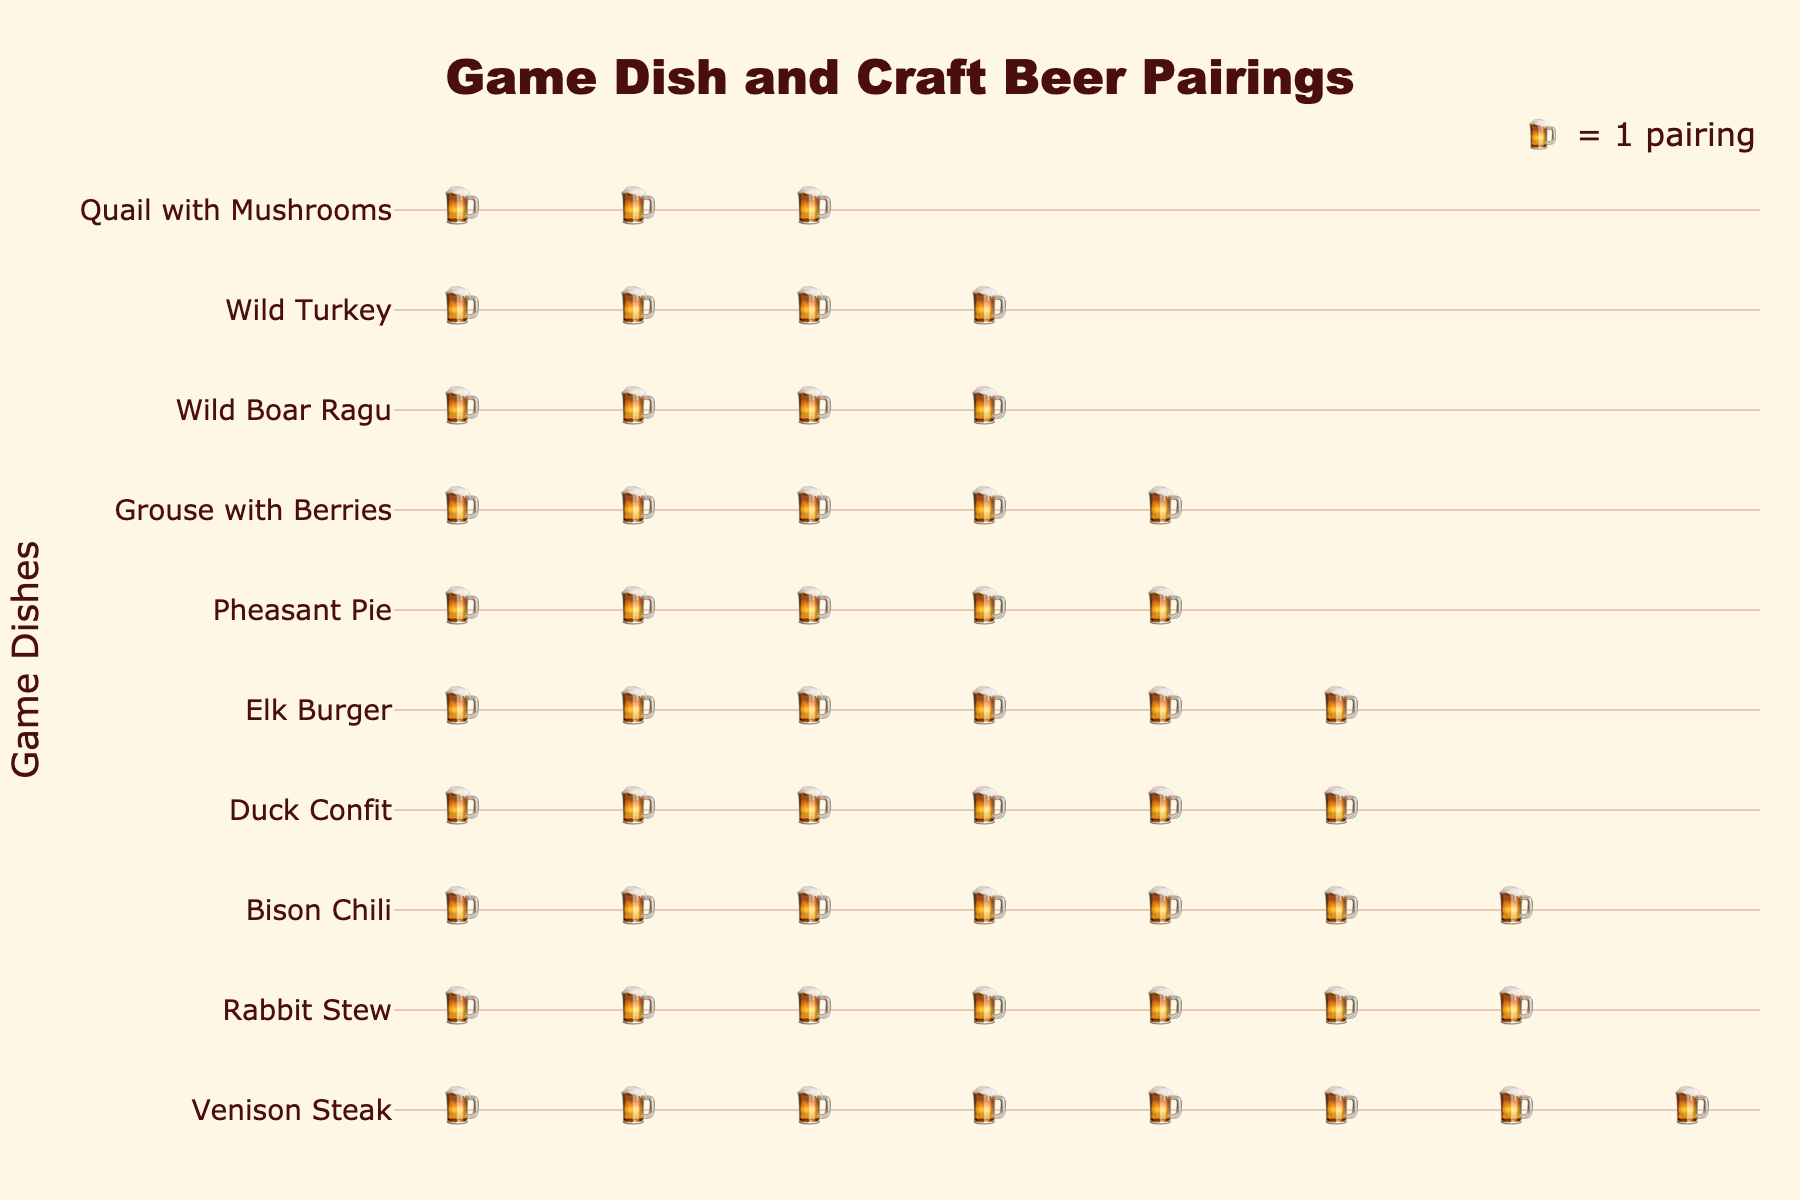what is the title of the plot? The title is typically placed at the top center of the plot. In this case, it should indicate the context of the data being visualized. The title reads "Game Dish and Craft Beer Pairings".
Answer: Game Dish and Craft Beer Pairings How many pairings are there for Bison Chili? Each beer mug icon represents one pairing. By counting the number of beer mugs next to Bison Chili, you can determine the total pairings. There are 7 beer mugs next to Bison Chili.
Answer: 7 Which game dish is paired with an Imperial Stout? The hover information typically includes the beer style along with the game dish. By looking at the icons and hover information, it's evident that an Imperial Stout is paired with Venison Steak.
Answer: Venison Steak What is the game dish with the least number of pairings? The dish with the least number of beer mugs next to it has the least pairings. By counting, Quail with Mushrooms has the fewest pairings with 3.
Answer: Quail with Mushrooms How many total pairings are depicted in the plot? Sum all the pairings for each game dish. These are: 8, 6, 5, 4, 7, 3, 5, 6, 4, 7. The total is 8 + 6 + 5 + 4 + 7 + 3 + 5 + 6 + 4 + 7 = 55.
Answer: 55 Which game dish has more pairings, Wild Boar Ragu or Rabbit Stew? Compare the number of beer mug icons next to each dish. Wild Boar Ragu has 4 pairings, and Rabbit Stew has 7 pairings. Rabbit Stew has more pairings.
Answer: Rabbit Stew What is the average number of pairings per game dish? To find the average, divide the total number of pairings by the number of game dishes. There are 55 total pairings across 10 dishes. 55 / 10 = 5.5.
Answer: 5.5 Which beer style is paired with Duck Confit? The hover information or pairing icons next to Duck Confit will show the beer style. Duck Confit is paired with Belgian Dubbel.
Answer: Belgian Dubbel How does the number of pairings for Elk Burger compare to that for American IPA? The same dish cannot have different beer styles; rather, we need to find the beer style for Elk Burger. Elk Burger is paired with American IPA with 6 pairings each, so they are the same.
Answer: Same What is the median number of pairings for the game dishes? To find the median, list the number of pairings in ascending order: 3, 4, 4, 5, 5, 6, 6, 7, 7, 8. The median is the average of the middle two numbers in this ordered list: (5+6) / 2 = 5.5.
Answer: 5.5 